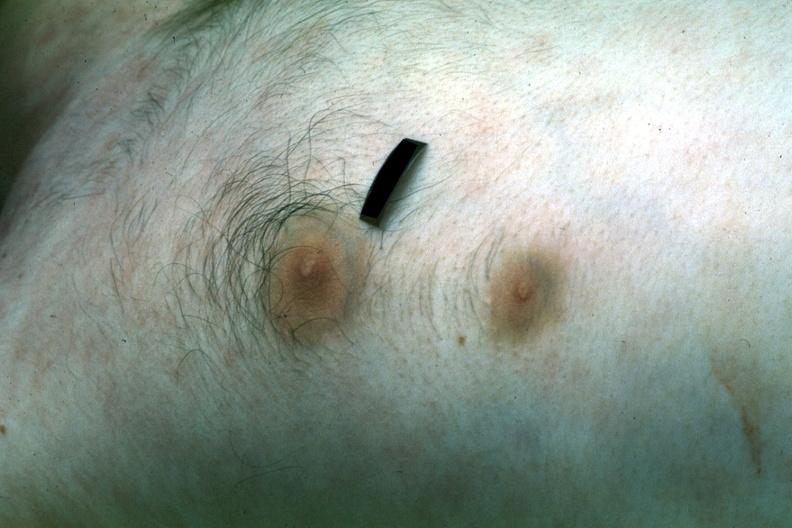what does this image show?
Answer the question using a single word or phrase. Two nipples 